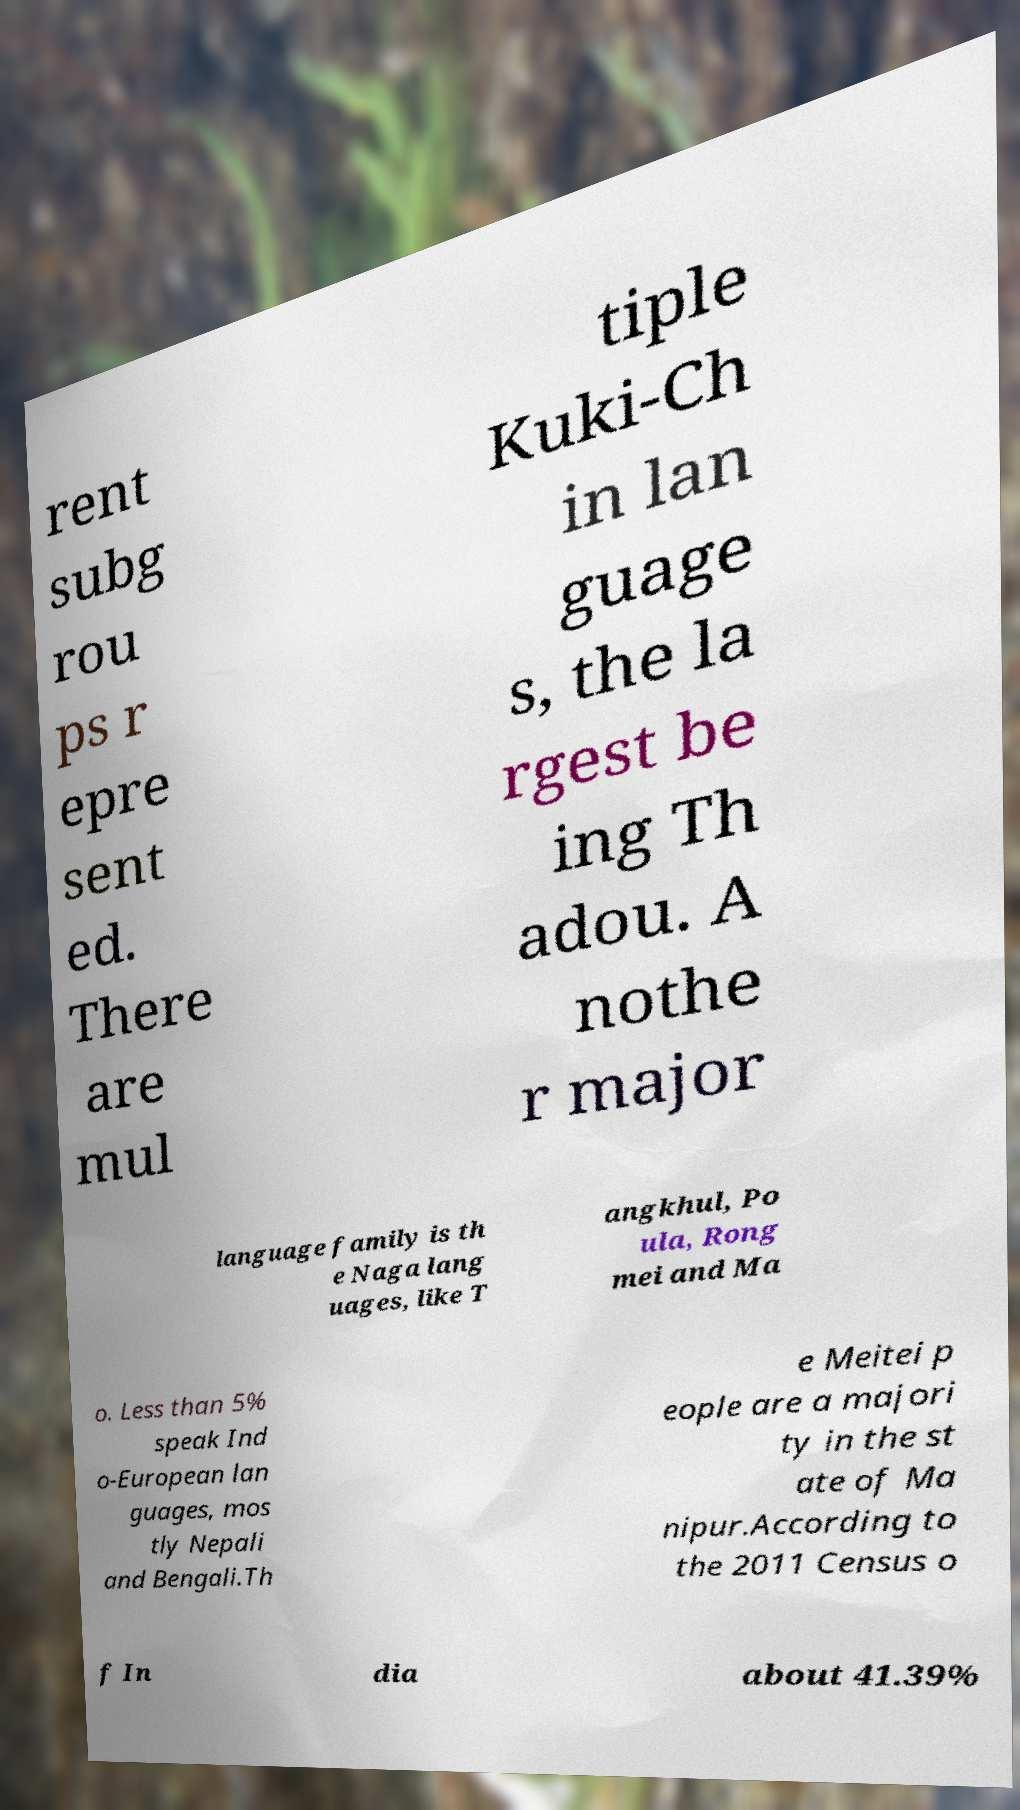There's text embedded in this image that I need extracted. Can you transcribe it verbatim? rent subg rou ps r epre sent ed. There are mul tiple Kuki-Ch in lan guage s, the la rgest be ing Th adou. A nothe r major language family is th e Naga lang uages, like T angkhul, Po ula, Rong mei and Ma o. Less than 5% speak Ind o-European lan guages, mos tly Nepali and Bengali.Th e Meitei p eople are a majori ty in the st ate of Ma nipur.According to the 2011 Census o f In dia about 41.39% 